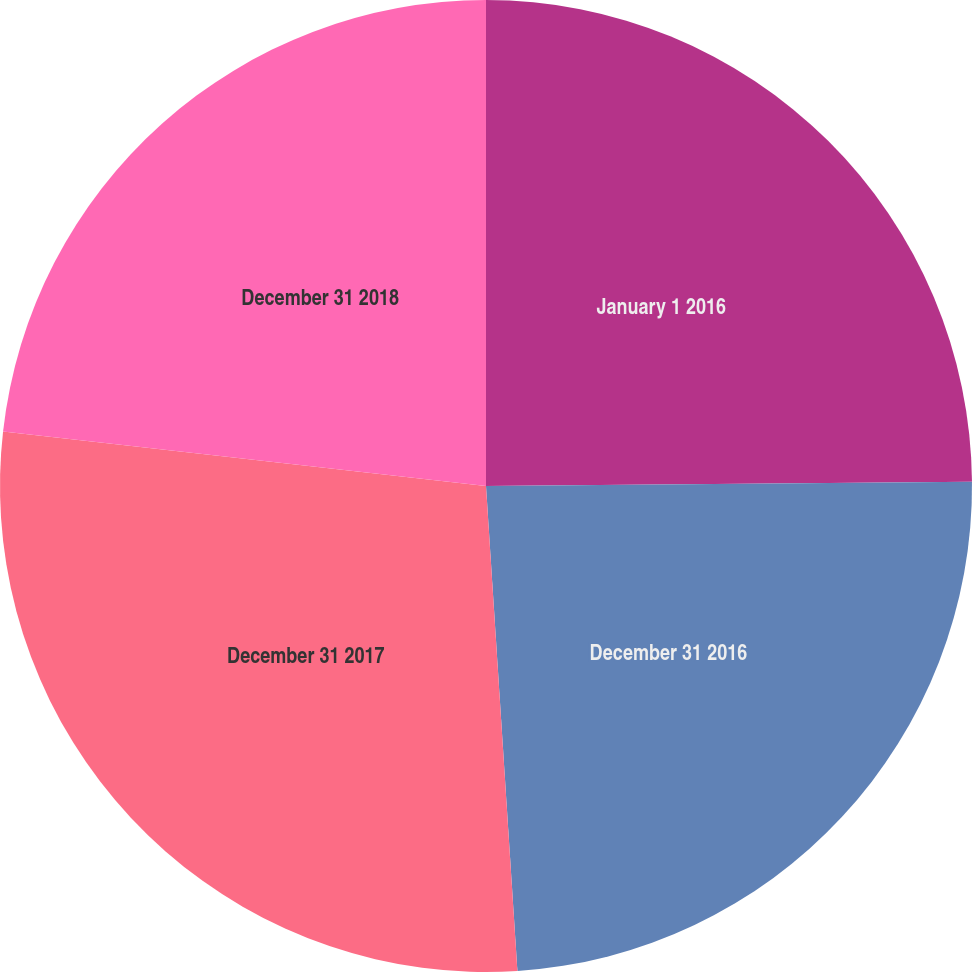<chart> <loc_0><loc_0><loc_500><loc_500><pie_chart><fcel>January 1 2016<fcel>December 31 2016<fcel>December 31 2017<fcel>December 31 2018<nl><fcel>24.86%<fcel>24.11%<fcel>27.82%<fcel>23.21%<nl></chart> 